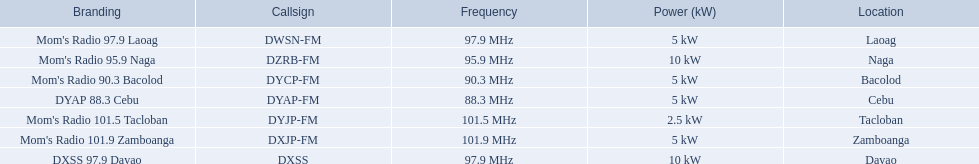Can you identify the stations that broadcast using dyap-fm? Mom's Radio 97.9 Laoag, Mom's Radio 95.9 Naga, Mom's Radio 90.3 Bacolod, DYAP 88.3 Cebu, Mom's Radio 101.5 Tacloban, Mom's Radio 101.9 Zamboanga, DXSS 97.9 Davao. Of these, which stations have a maximum power output of 5kw or less? Mom's Radio 97.9 Laoag, Mom's Radio 90.3 Bacolod, DYAP 88.3 Cebu, Mom's Radio 101.5 Tacloban, Mom's Radio 101.9 Zamboanga. From this subset, which station has the smallest broadcasting power? Mom's Radio 101.5 Tacloban. 